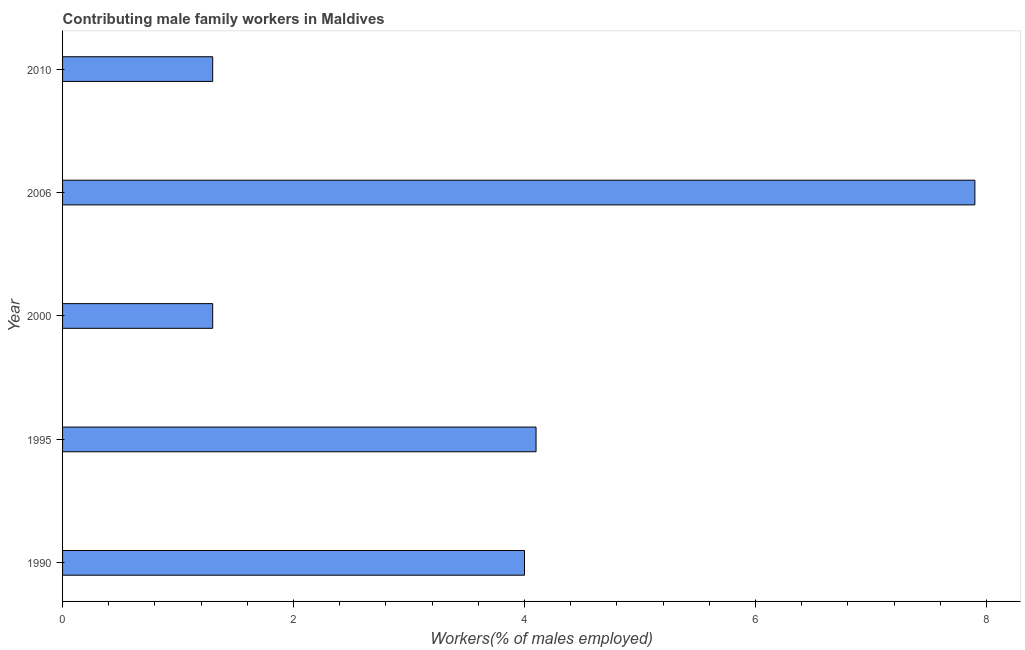Does the graph contain grids?
Ensure brevity in your answer.  No. What is the title of the graph?
Offer a very short reply. Contributing male family workers in Maldives. What is the label or title of the X-axis?
Offer a terse response. Workers(% of males employed). Across all years, what is the maximum contributing male family workers?
Offer a very short reply. 7.9. Across all years, what is the minimum contributing male family workers?
Provide a short and direct response. 1.3. In which year was the contributing male family workers minimum?
Keep it short and to the point. 2000. What is the sum of the contributing male family workers?
Give a very brief answer. 18.6. What is the average contributing male family workers per year?
Provide a succinct answer. 3.72. What is the ratio of the contributing male family workers in 1990 to that in 1995?
Give a very brief answer. 0.98. Is the contributing male family workers in 1995 less than that in 2006?
Ensure brevity in your answer.  Yes. Is the difference between the contributing male family workers in 1990 and 1995 greater than the difference between any two years?
Provide a short and direct response. No. What is the difference between the highest and the second highest contributing male family workers?
Your response must be concise. 3.8. Is the sum of the contributing male family workers in 1990 and 2000 greater than the maximum contributing male family workers across all years?
Keep it short and to the point. No. What is the difference between the highest and the lowest contributing male family workers?
Offer a very short reply. 6.6. What is the difference between two consecutive major ticks on the X-axis?
Your answer should be compact. 2. Are the values on the major ticks of X-axis written in scientific E-notation?
Provide a short and direct response. No. What is the Workers(% of males employed) of 1995?
Your response must be concise. 4.1. What is the Workers(% of males employed) in 2000?
Your answer should be compact. 1.3. What is the Workers(% of males employed) of 2006?
Offer a terse response. 7.9. What is the Workers(% of males employed) of 2010?
Your answer should be compact. 1.3. What is the difference between the Workers(% of males employed) in 1990 and 2000?
Your answer should be compact. 2.7. What is the difference between the Workers(% of males employed) in 1990 and 2010?
Provide a short and direct response. 2.7. What is the difference between the Workers(% of males employed) in 2000 and 2006?
Give a very brief answer. -6.6. What is the difference between the Workers(% of males employed) in 2000 and 2010?
Provide a short and direct response. 0. What is the ratio of the Workers(% of males employed) in 1990 to that in 2000?
Your answer should be very brief. 3.08. What is the ratio of the Workers(% of males employed) in 1990 to that in 2006?
Make the answer very short. 0.51. What is the ratio of the Workers(% of males employed) in 1990 to that in 2010?
Ensure brevity in your answer.  3.08. What is the ratio of the Workers(% of males employed) in 1995 to that in 2000?
Make the answer very short. 3.15. What is the ratio of the Workers(% of males employed) in 1995 to that in 2006?
Provide a short and direct response. 0.52. What is the ratio of the Workers(% of males employed) in 1995 to that in 2010?
Give a very brief answer. 3.15. What is the ratio of the Workers(% of males employed) in 2000 to that in 2006?
Make the answer very short. 0.17. What is the ratio of the Workers(% of males employed) in 2006 to that in 2010?
Your answer should be very brief. 6.08. 